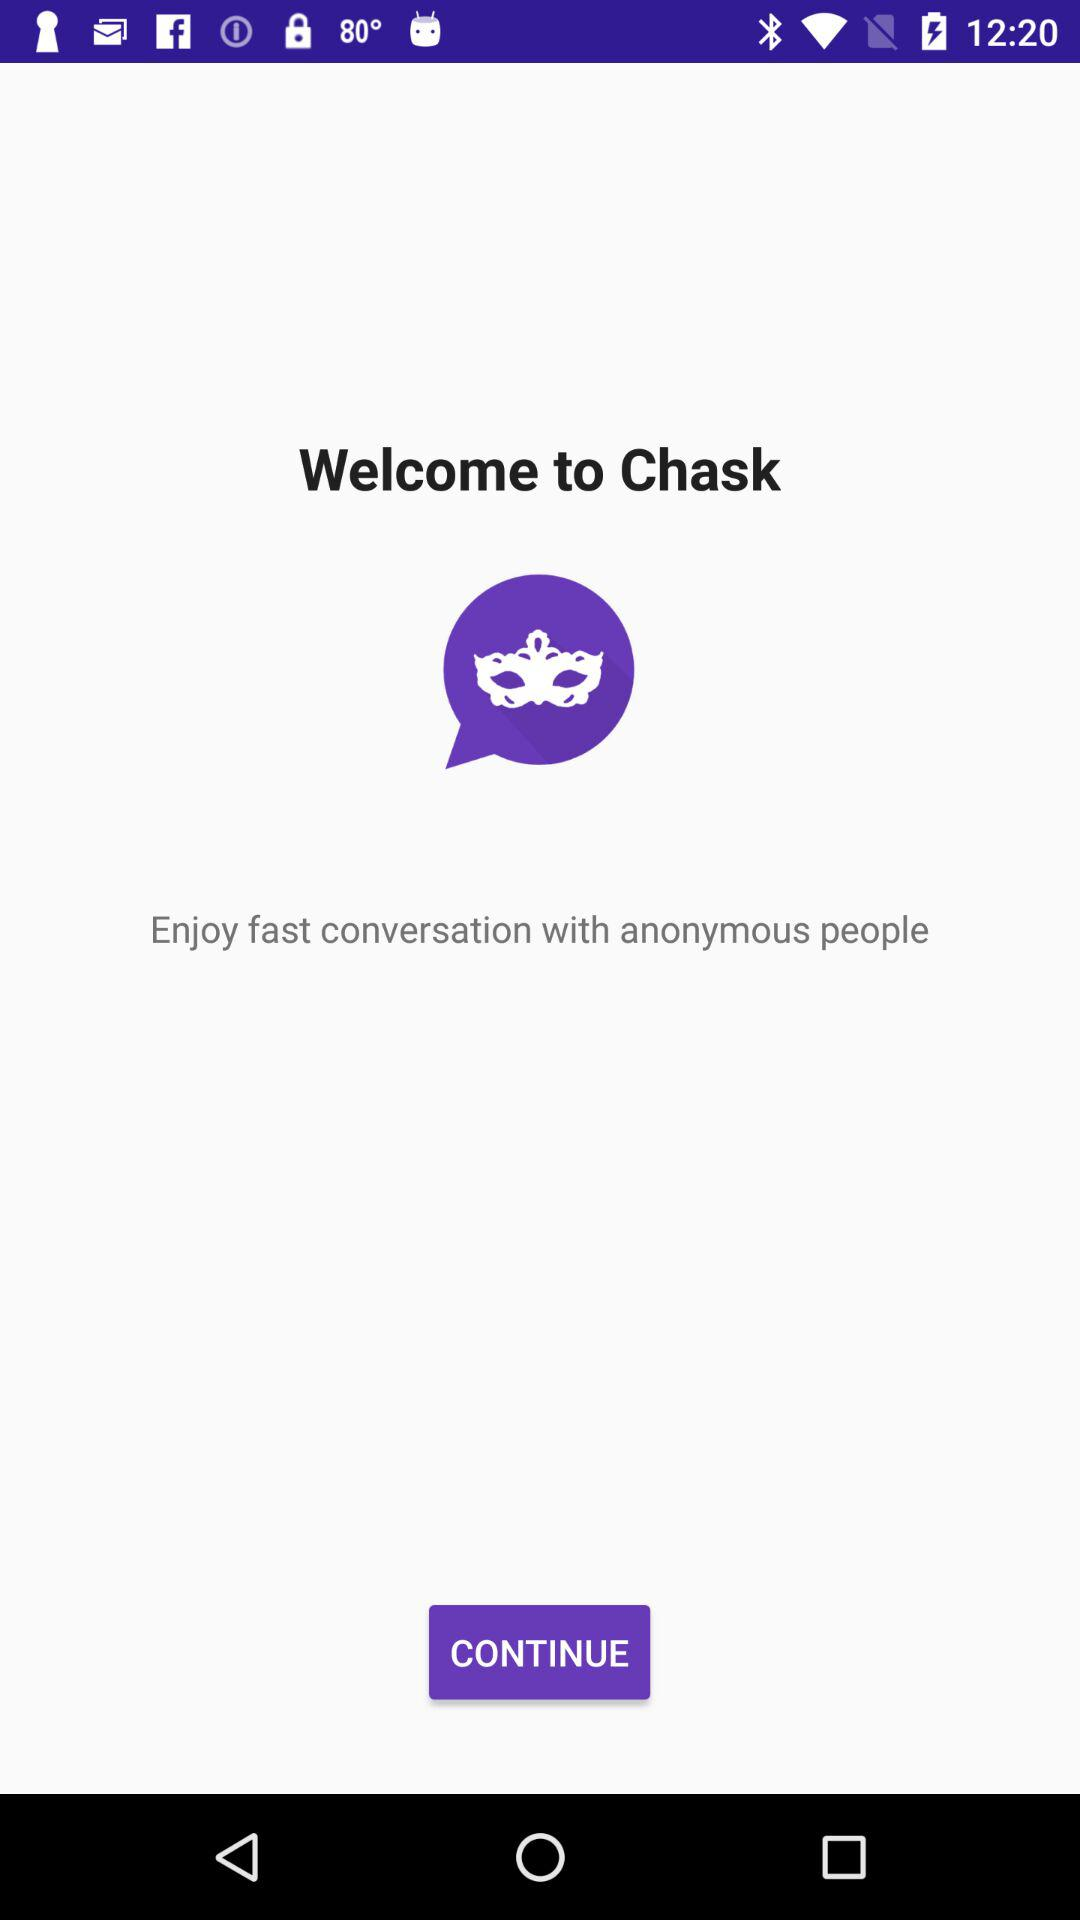What is the app name? The app name is "Chask". 